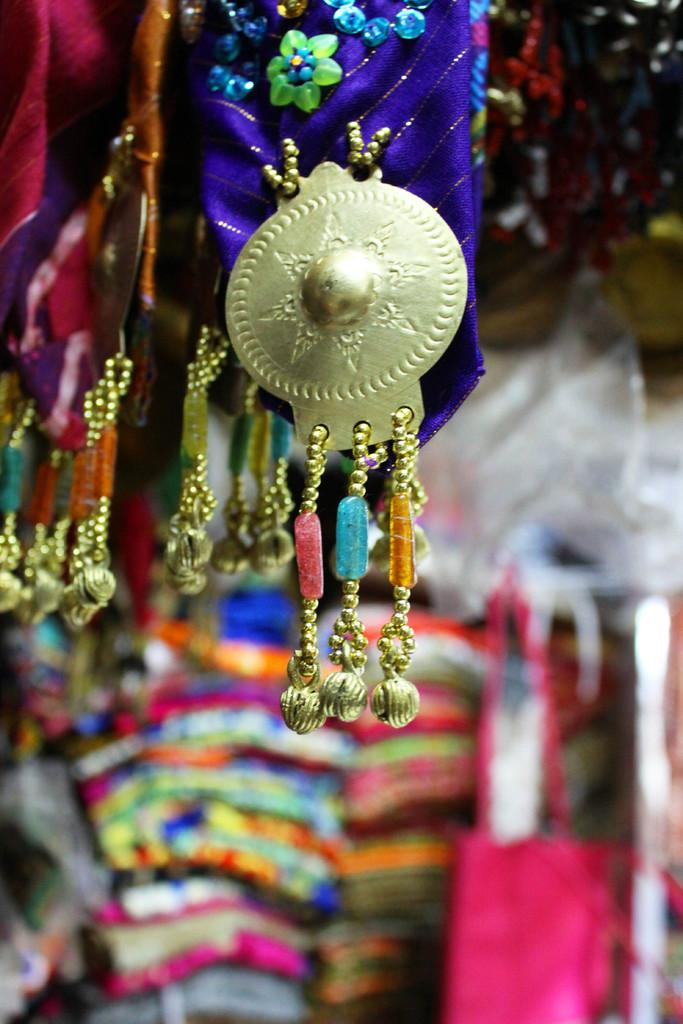What type of objects can be seen in the image? There are decorative items visible in the image. How are the decorative items connected to the main subject? The decorative items are attached to clothes. Where is the mailbox located in the image? There is no mailbox present in the image. Can you see a plane flying in the background of the image? There is no plane visible in the image. Is there a beetle crawling on the clothes in the image? There is no beetle present in the image. 